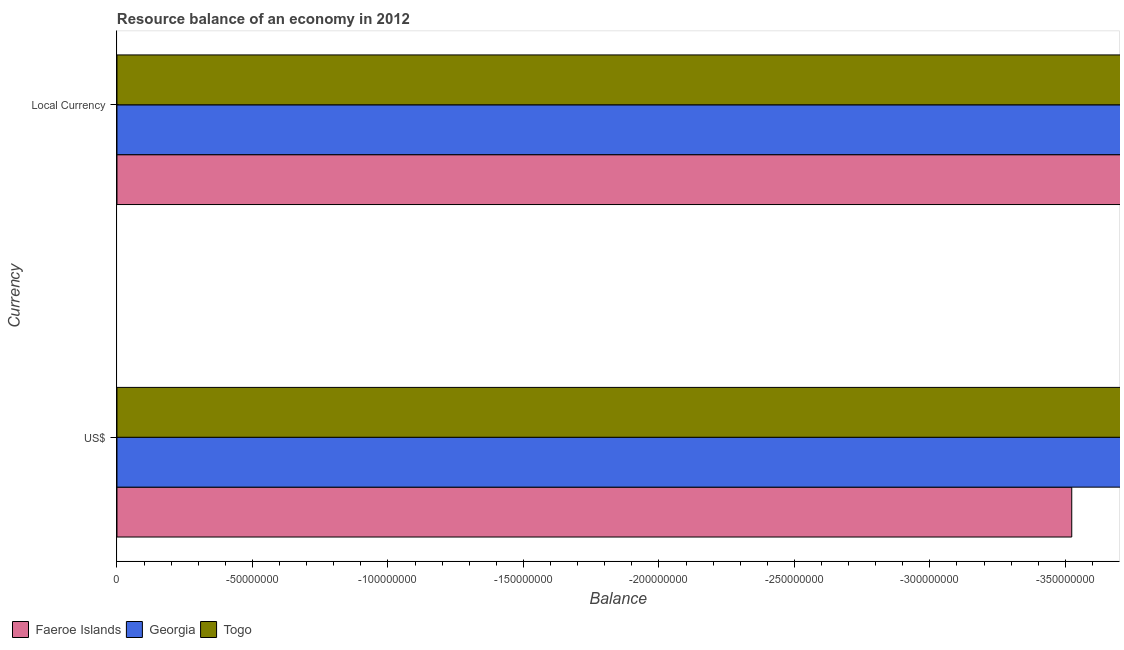Are the number of bars per tick equal to the number of legend labels?
Offer a very short reply. No. Are the number of bars on each tick of the Y-axis equal?
Keep it short and to the point. Yes. What is the label of the 2nd group of bars from the top?
Make the answer very short. US$. Across all countries, what is the minimum resource balance in constant us$?
Provide a short and direct response. 0. What is the total resource balance in us$ in the graph?
Offer a very short reply. 0. What is the difference between the resource balance in us$ in Togo and the resource balance in constant us$ in Georgia?
Make the answer very short. 0. Are all the bars in the graph horizontal?
Keep it short and to the point. Yes. What is the difference between two consecutive major ticks on the X-axis?
Keep it short and to the point. 5.00e+07. Does the graph contain grids?
Make the answer very short. No. What is the title of the graph?
Keep it short and to the point. Resource balance of an economy in 2012. Does "Kiribati" appear as one of the legend labels in the graph?
Your answer should be very brief. No. What is the label or title of the X-axis?
Make the answer very short. Balance. What is the label or title of the Y-axis?
Ensure brevity in your answer.  Currency. What is the Balance in Faeroe Islands in US$?
Provide a succinct answer. 0. What is the Balance of Georgia in US$?
Your response must be concise. 0. What is the Balance in Togo in US$?
Make the answer very short. 0. What is the Balance of Georgia in Local Currency?
Your response must be concise. 0. What is the Balance in Togo in Local Currency?
Ensure brevity in your answer.  0. What is the total Balance of Georgia in the graph?
Give a very brief answer. 0. 